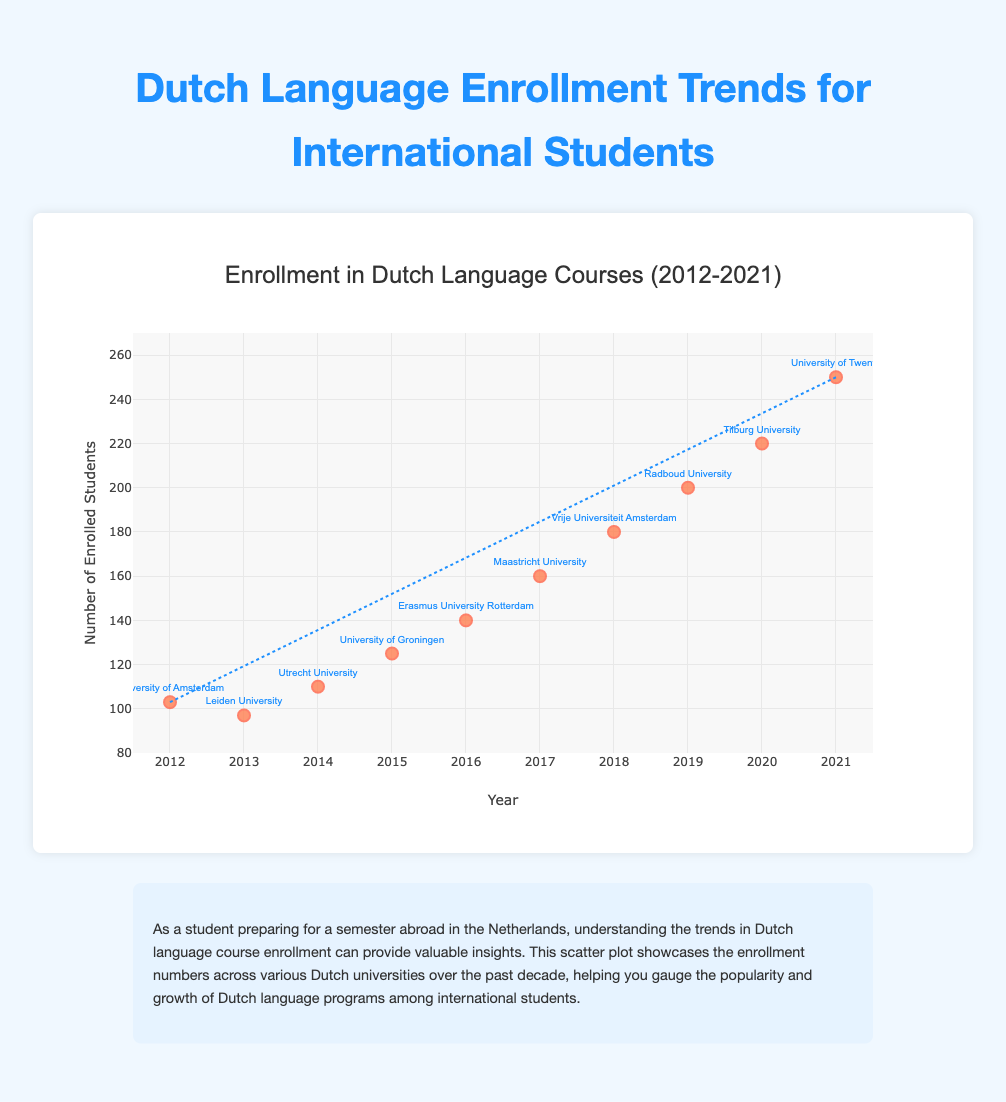What is the title of the chart? The title of the chart is typically displayed at the top of the figure. In this case, it is indicated in the `title` section of the `layout` object.
Answer: Enrollment in Dutch Language Courses (2012-2021) What does the x-axis represent in the chart? The x-axis is labeled with a title that describes what it represents. According to the `layout` settings, the x-axis represents the year.
Answer: Year How many total data points are shown in the scatter plot? Each data point represents an enrollment number for a given year and university. By counting the number of entries in the `data` array, we can determine there are 10 data points.
Answer: 10 Which university had the highest enrollment in Dutch language courses in 2021? The enrollment for each university in a given year can be located in the data points. The data for 2021 shows the highest enrollment at the University of Twente.
Answer: University of Twente What is the trend of enrollment in Dutch language courses over the decade? The trend line added to the scatter plot indicates the overall direction of the data points. The line moves from the lower-left to the upper-right, suggesting an increasing trend in enrollments.
Answer: Increasing Which university had the lowest enrollment and in which year? To find the lowest enrollment, we identify the smallest value in the `Enrollment` field of the `data` array. The lowest enrollment of 97 occurred at Leiden University in 2013.
Answer: Leiden University, 2013 What is the total enrollment across all universities in 2019? The enrollment for 2019 is shown as 200 for Radboud University. Since this is the only data point for that year, the total enrollment is simply that value.
Answer: 200 What is the average yearly increase in enrollment over the decade? To calculate this, we find the difference between the 2021 and 2012 enrollments and divide by the number of years spanning the decade (2021 - 2012 = 9 years). The increase is (250 - 103) / 9.
Answer: 16.33 Compare the enrollment between 2015 and 2017. Which year had higher enrollment and by how much? The enrollment in 2015 is 125 and in 2017 is 160. The difference is 160 - 125.
Answer: 2017 by 35 Do any universities appear more than once in the dataset? By scanning through the entries in the `University` field in the data array, each university is unique and does not repeat.
Answer: No 